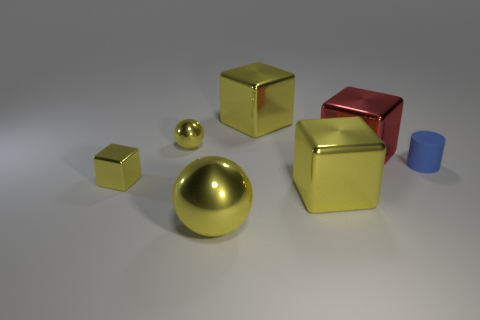Subtract all yellow cubes. How many were subtracted if there are2yellow cubes left? 1 Subtract all purple cylinders. How many yellow blocks are left? 3 Subtract 1 cubes. How many cubes are left? 3 Add 2 blue matte things. How many objects exist? 9 Subtract all cylinders. How many objects are left? 6 Subtract all tiny metal things. Subtract all large yellow spheres. How many objects are left? 4 Add 1 large yellow balls. How many large yellow balls are left? 2 Add 3 red metal objects. How many red metal objects exist? 4 Subtract 1 blue cylinders. How many objects are left? 6 